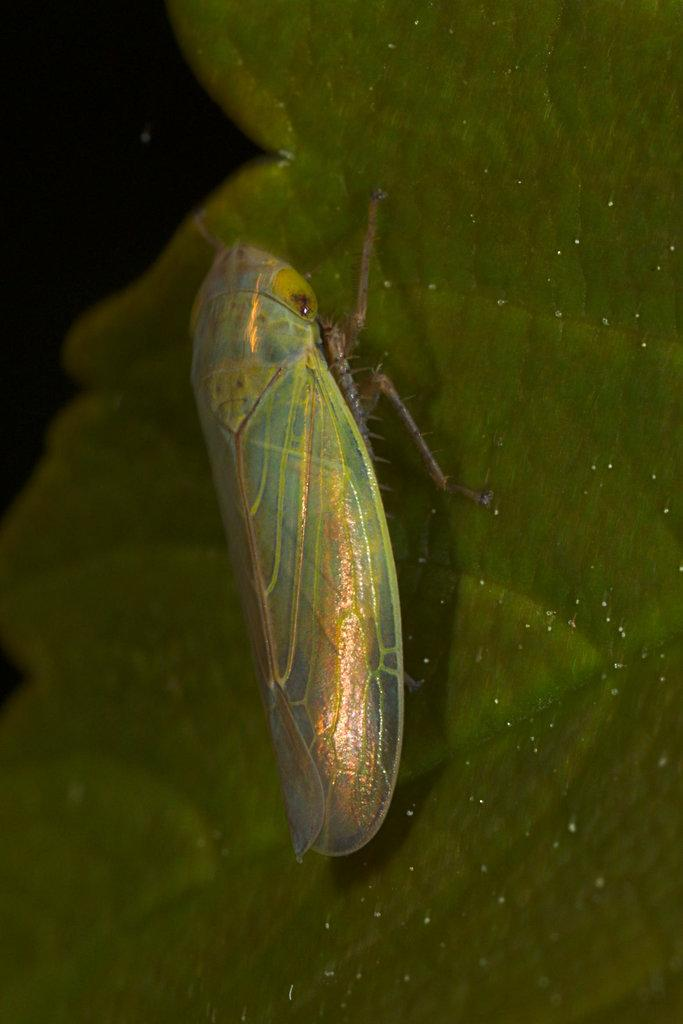What is present on the leaf in the image? There is an insect on a leaf in the image. What can be observed about the background of the image? The background of the image is dark. What type of clover is the insect using as a landing pad in the image? There is no clover present in the image; it features an insect on a leaf. What type of stew is the insect preparing in the image? There is no stew or indication of cooking in the image; it features an insect on a leaf. 